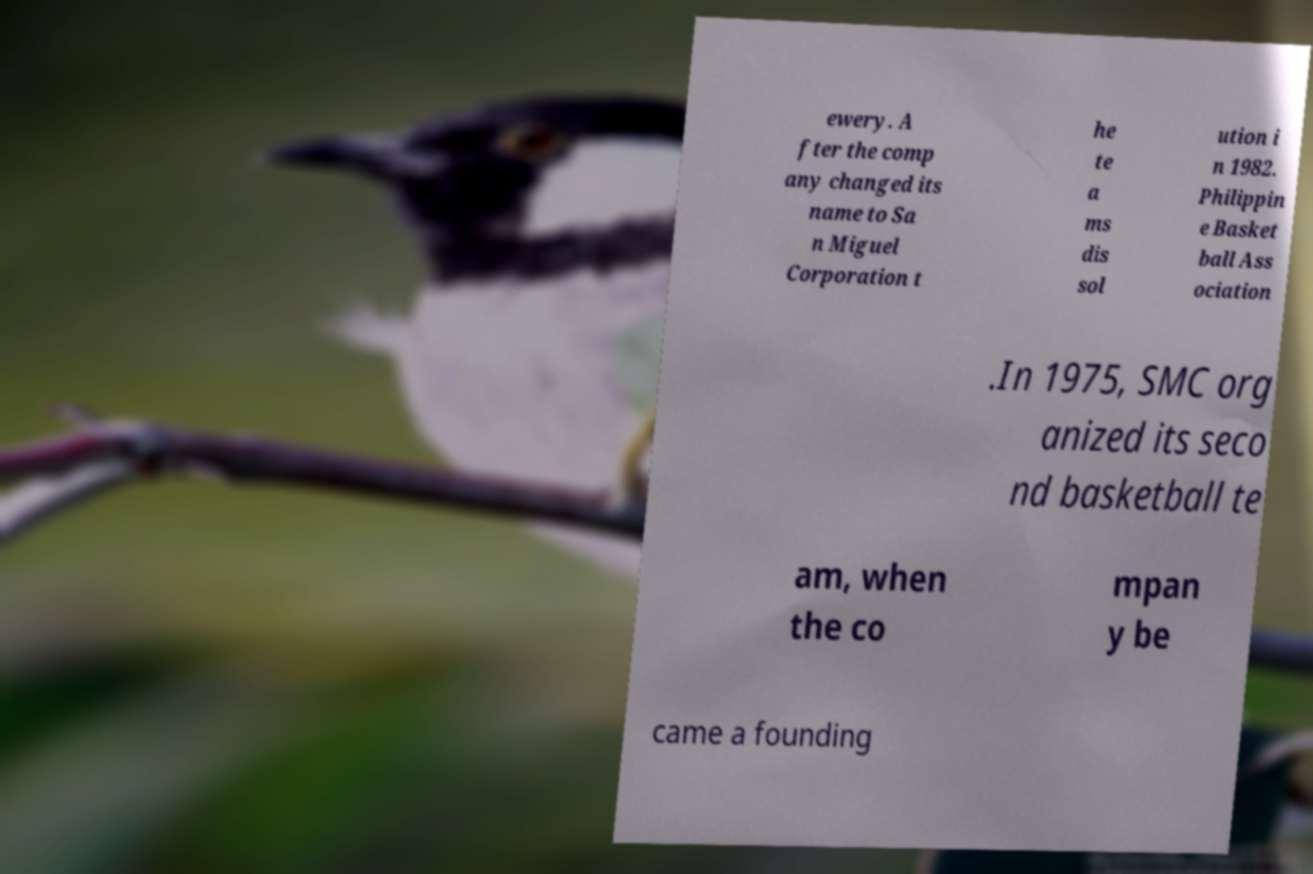What messages or text are displayed in this image? I need them in a readable, typed format. ewery. A fter the comp any changed its name to Sa n Miguel Corporation t he te a ms dis sol ution i n 1982. Philippin e Basket ball Ass ociation .In 1975, SMC org anized its seco nd basketball te am, when the co mpan y be came a founding 